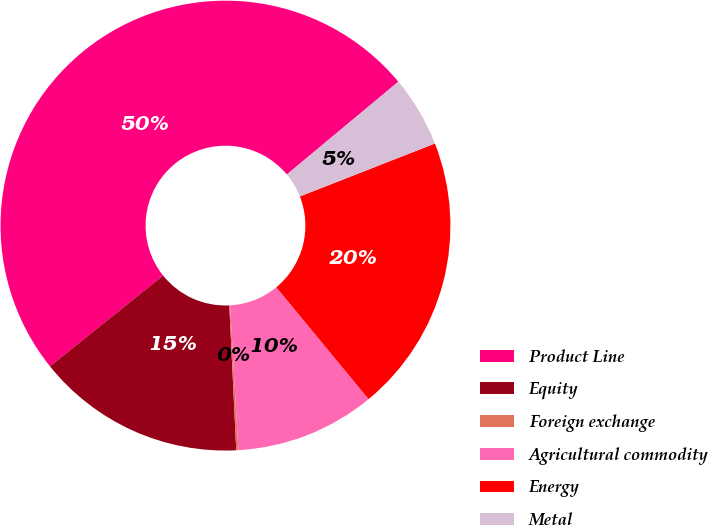Convert chart to OTSL. <chart><loc_0><loc_0><loc_500><loc_500><pie_chart><fcel>Product Line<fcel>Equity<fcel>Foreign exchange<fcel>Agricultural commodity<fcel>Energy<fcel>Metal<nl><fcel>49.7%<fcel>15.01%<fcel>0.15%<fcel>10.06%<fcel>19.97%<fcel>5.1%<nl></chart> 